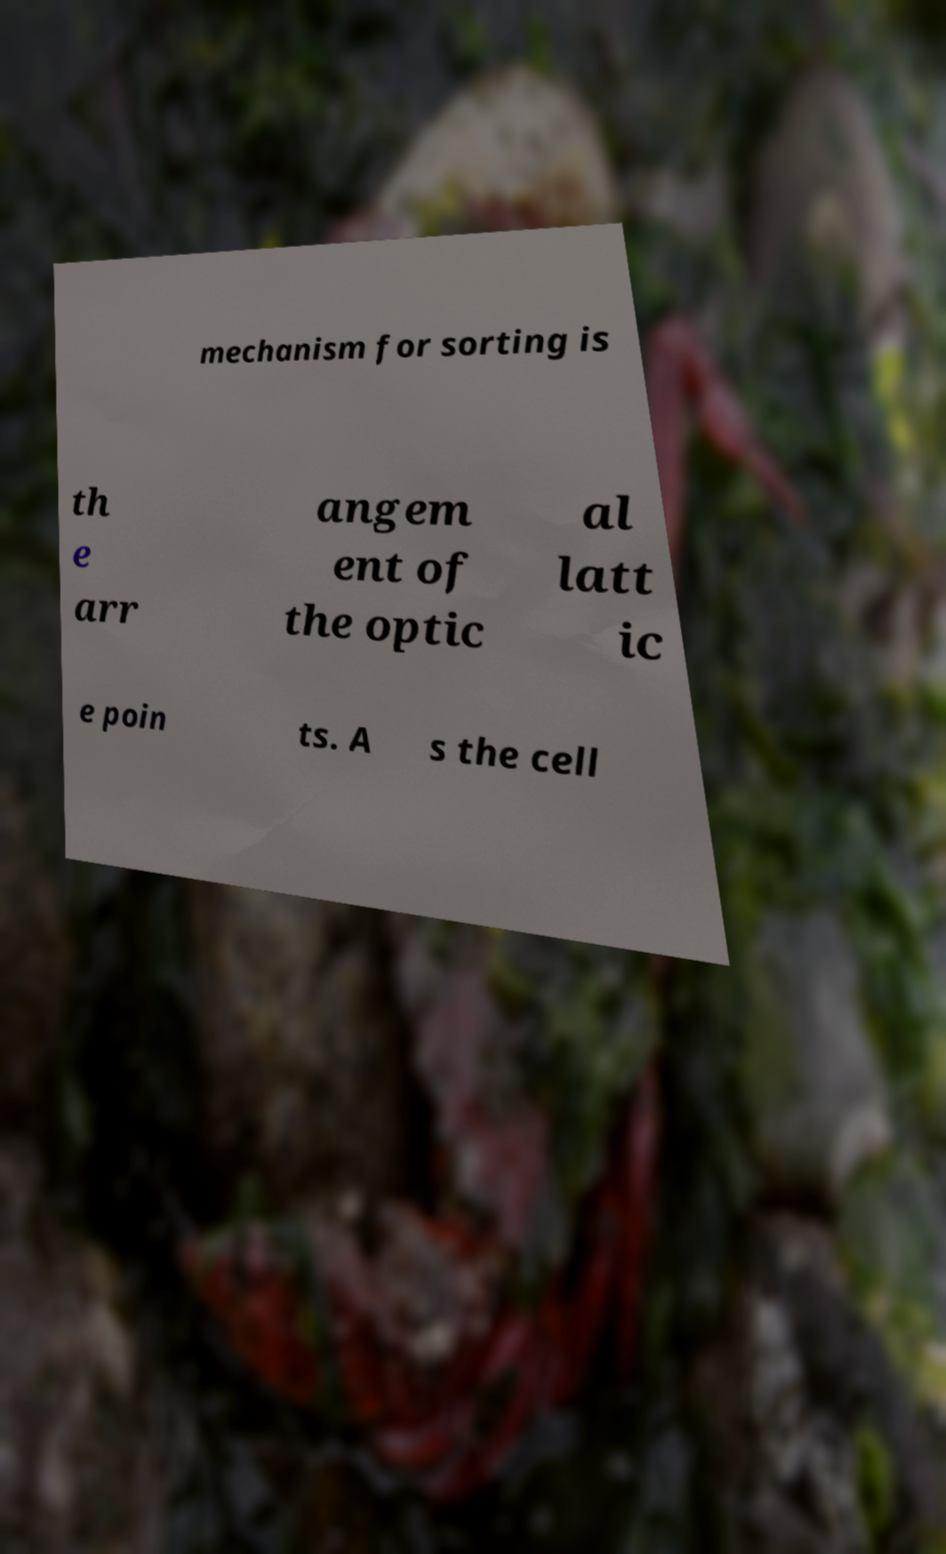Could you assist in decoding the text presented in this image and type it out clearly? mechanism for sorting is th e arr angem ent of the optic al latt ic e poin ts. A s the cell 